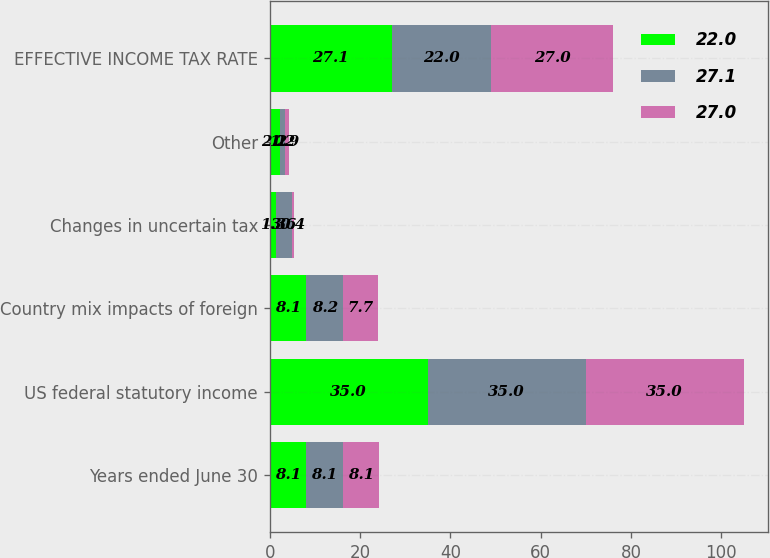Convert chart to OTSL. <chart><loc_0><loc_0><loc_500><loc_500><stacked_bar_chart><ecel><fcel>Years ended June 30<fcel>US federal statutory income<fcel>Country mix impacts of foreign<fcel>Changes in uncertain tax<fcel>Other<fcel>EFFECTIVE INCOME TAX RATE<nl><fcel>22<fcel>8.1<fcel>35<fcel>8.1<fcel>1.3<fcel>2.2<fcel>27.1<nl><fcel>27.1<fcel>8.1<fcel>35<fcel>8.2<fcel>3.6<fcel>1.2<fcel>22<nl><fcel>27<fcel>8.1<fcel>35<fcel>7.7<fcel>0.4<fcel>0.9<fcel>27<nl></chart> 